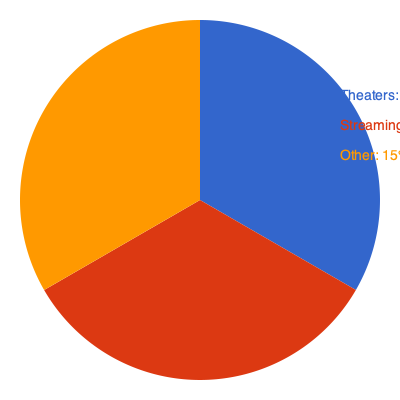The pie chart shows the revenue distribution for a blockbuster movie. Given that the total revenue is $500 million, how much more revenue did theaters generate compared to streaming platforms? To solve this problem, we need to follow these steps:

1. Identify the percentages for theaters and streaming:
   - Theaters: 45%
   - Streaming: 40%

2. Calculate the total revenue for each distribution channel:
   - Theaters: $500 million × 45% = $500 million × 0.45 = $225 million
   - Streaming: $500 million × 40% = $500 million × 0.40 = $200 million

3. Calculate the difference between theater and streaming revenue:
   $225 million - $200 million = $25 million

Therefore, theaters generated $25 million more revenue than streaming platforms for this blockbuster movie.
Answer: $25 million 